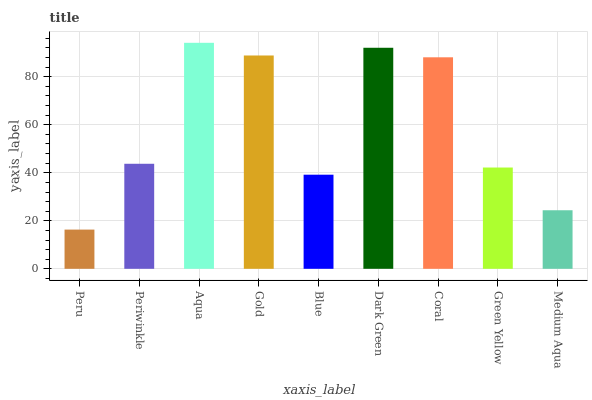Is Peru the minimum?
Answer yes or no. Yes. Is Aqua the maximum?
Answer yes or no. Yes. Is Periwinkle the minimum?
Answer yes or no. No. Is Periwinkle the maximum?
Answer yes or no. No. Is Periwinkle greater than Peru?
Answer yes or no. Yes. Is Peru less than Periwinkle?
Answer yes or no. Yes. Is Peru greater than Periwinkle?
Answer yes or no. No. Is Periwinkle less than Peru?
Answer yes or no. No. Is Periwinkle the high median?
Answer yes or no. Yes. Is Periwinkle the low median?
Answer yes or no. Yes. Is Medium Aqua the high median?
Answer yes or no. No. Is Gold the low median?
Answer yes or no. No. 